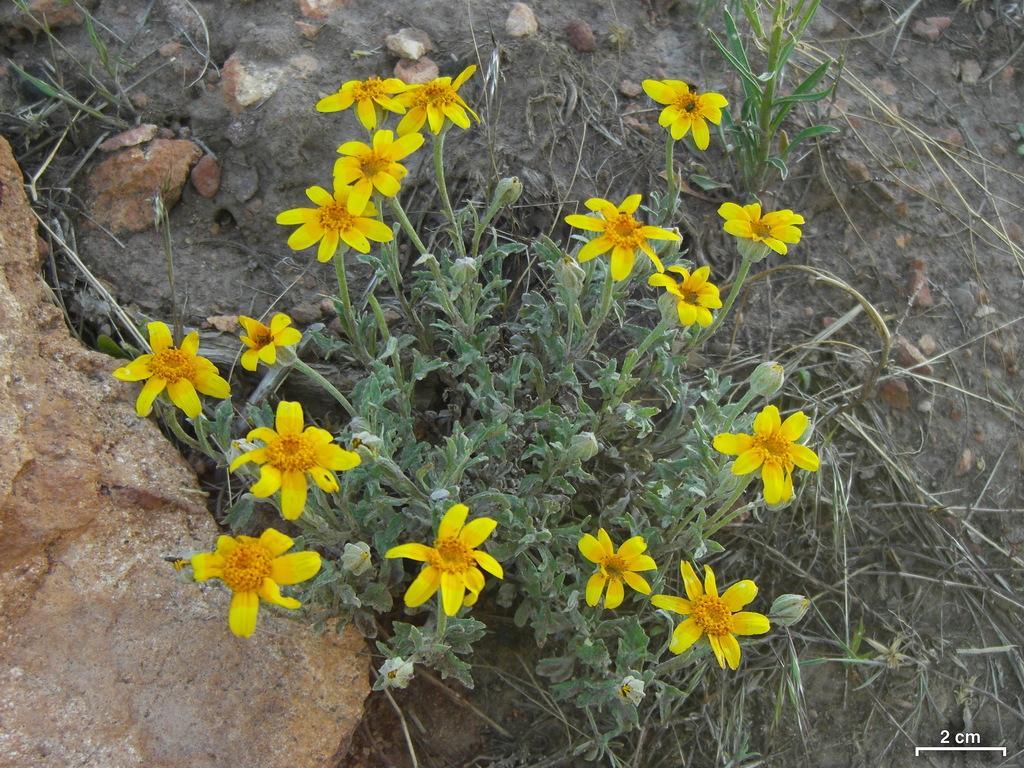Could you give a brief overview of what you see in this image? In this picture we can see flowers, buds, leaves and in the background we can see stones. 